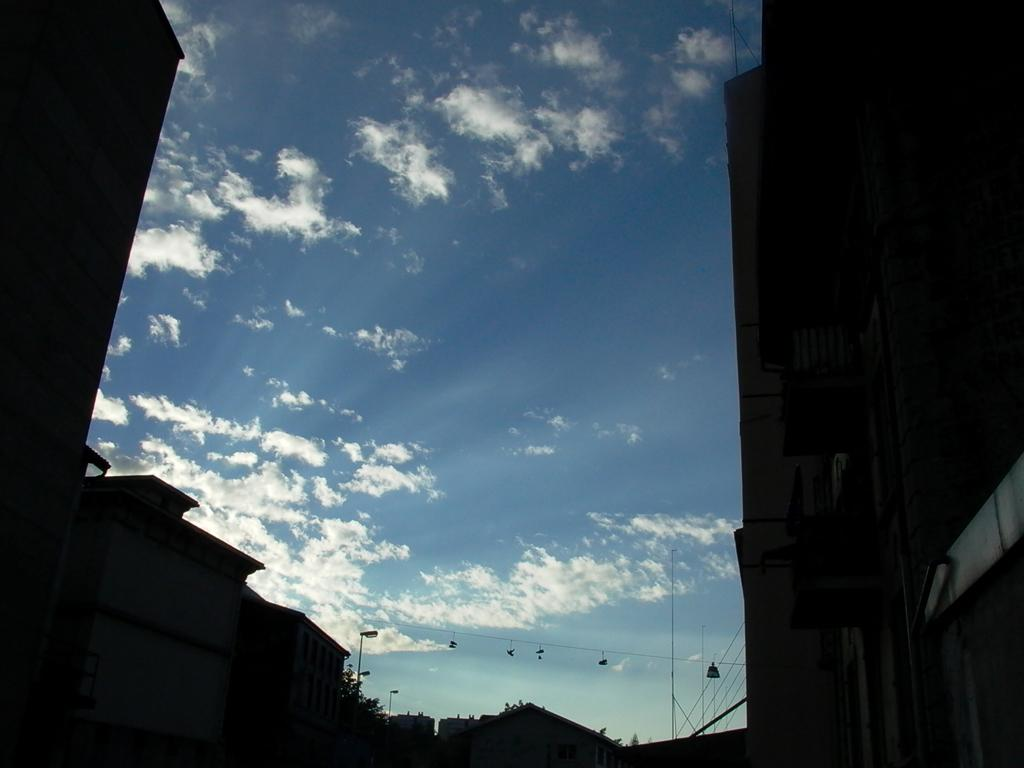What type of structures can be seen in the image? There are buildings in the image. What can be seen illuminating the area in the image? There are street lights in the image. What else is present in the image besides buildings and street lights? There are wires in the image. What type of mitten is being used to polish the blade in the image? There is no mitten, polish, or blade present in the image. 